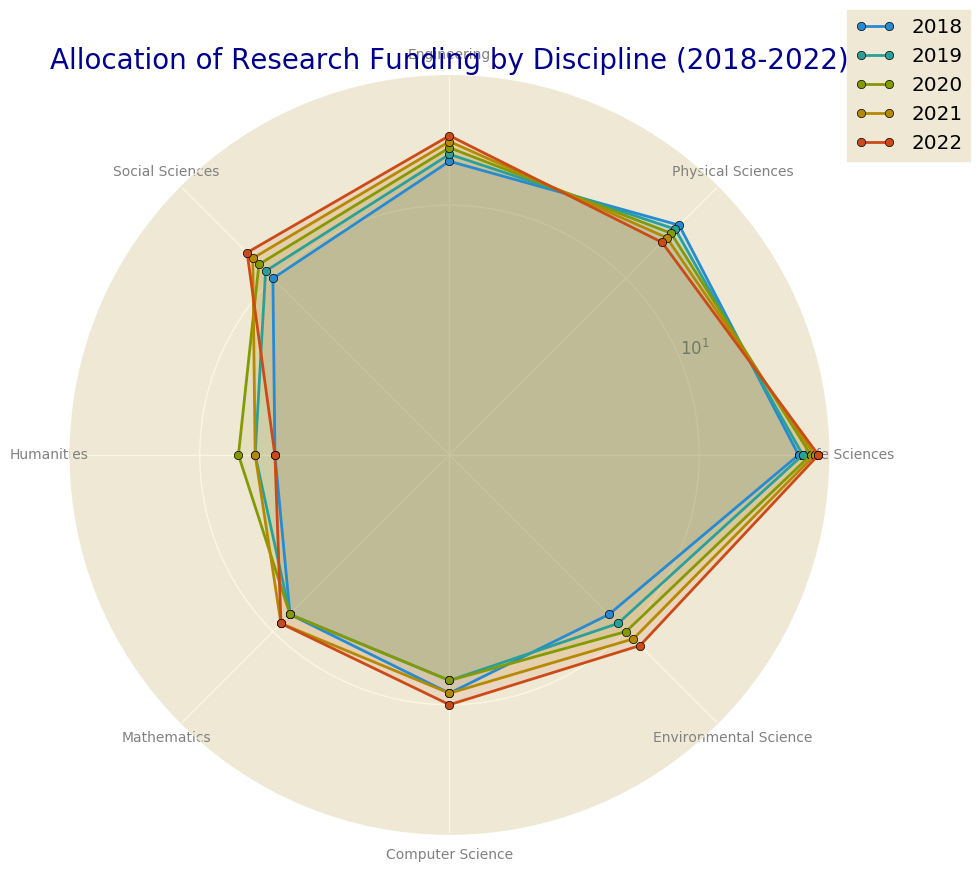What scientific discipline received the highest funding in 2022? Observing the plot, the Life Sciences discipline reaches the highest point in 2022, compared to other disciplines.
Answer: Life Sciences How did the funding trend for Humanities change from 2018 to 2022? Noting the line representing Humanities, funding rises from 5 in 2018 to 7 in 2020, then drops to 6 in 2021 and 5 in 2022, showing a non-consistent pattern.
Answer: Increased, then decreased Which year showed a decrease in funding for Computer Science compared to the previous year? Examining the Computer Science line, funding decreases from 9 in 2018 to 8 in 2019.
Answer: 2019 Which two disciplines have converging funding allocations from 2018 to 2022? Comparing the trends, Engineering and Environmental Science show converging patterns towards 2022, where their funding values are very close.
Answer: Engineering and Environmental Science What is the average funding for Physical Sciences across the five years? Adding the funding amounts for Physical Sciences (20, 19, 18, 17, 16) and dividing by 5 yields (20+19+18+17+16)/5 = 18
Answer: 18 Which discipline has the most consistent funding allocation over the five years? Considering consistency in the shape of plots, Mathematics has the most consistent funding values, staying mostly flat around 8 and moving slightly to 9.
Answer: Mathematics How much more funding did Life Sciences have compared to Humanities in 2022? Subtracting the Humanities funding (5) from Life Sciences funding (30) for 2022: 30 - 5 = 25
Answer: 25 What was the funding trend for Social Sciences from 2018 to 2022? Observing the trend, Social Sciences funding consistently increases every year from 10 in 2018 to 14 in 2022.
Answer: Consistently increasing Which discipline had decreasing funding every year from 2018 to 2022? Physical Sciences funding shows a downward trend each year from 20 in 2018 to 16 in 2022.
Answer: Physical Sciences What is the funding difference between the highest and lowest funded discipline in 2022? The highest funding is for Life Sciences at 30, and the lowest is Humanities at 5. The difference is 30 - 5 = 25.
Answer: 25 